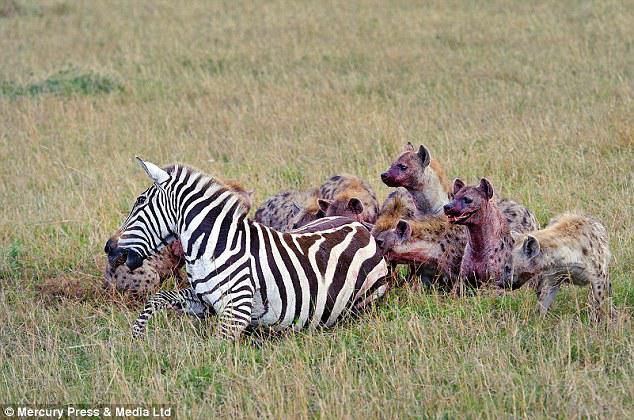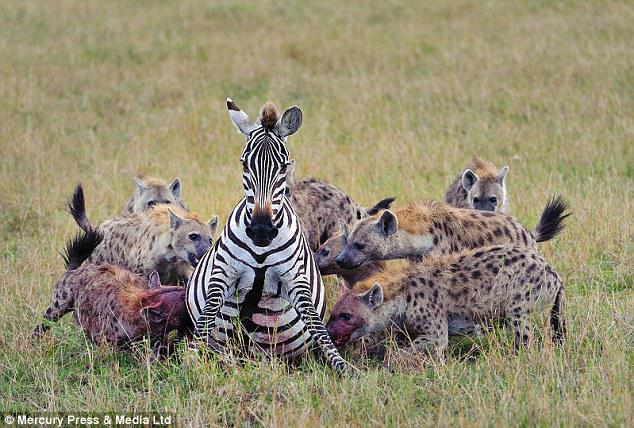The first image is the image on the left, the second image is the image on the right. Examine the images to the left and right. Is the description "The target of the hyenas appears to still be alive in both images." accurate? Answer yes or no. Yes. The first image is the image on the left, the second image is the image on the right. Evaluate the accuracy of this statement regarding the images: "There is no more than one hyena in the right image.". Is it true? Answer yes or no. No. 